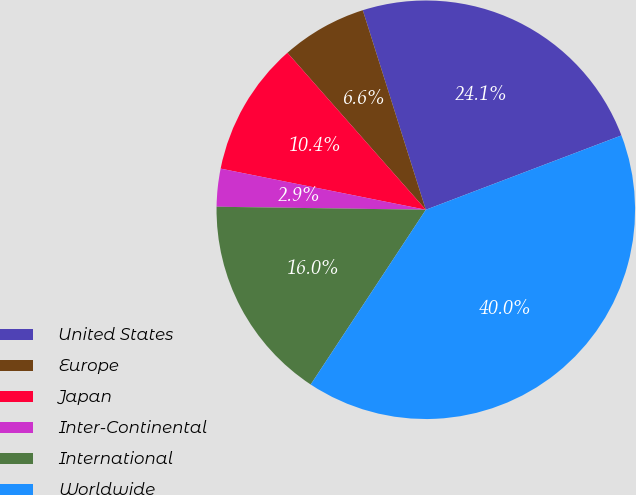<chart> <loc_0><loc_0><loc_500><loc_500><pie_chart><fcel>United States<fcel>Europe<fcel>Japan<fcel>Inter-Continental<fcel>International<fcel>Worldwide<nl><fcel>24.09%<fcel>6.63%<fcel>10.35%<fcel>2.92%<fcel>15.96%<fcel>40.05%<nl></chart> 